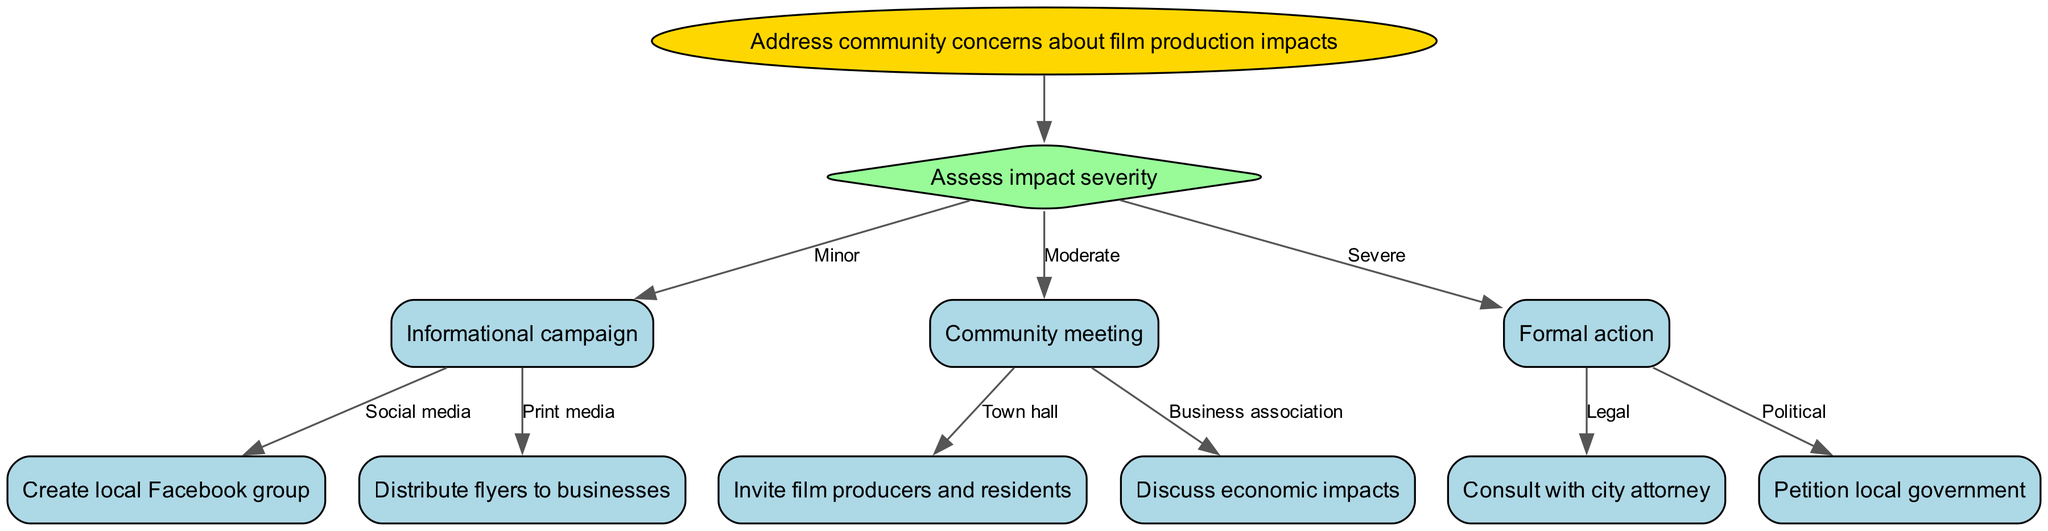What is the main goal of the decision tree? The root of the decision tree indicates that the primary focus is to "Address community concerns about film production impacts," which sets the context for the entire diagram.
Answer: Address community concerns about film production impacts How many options are available for moderate impact severity? The node for moderate impact severity presents two options: "Community meeting" allows for two specific actions, which are listed as separate paths.
Answer: 2 What is the first step if the impact is assessed as severe? The decision tree specifies that for severe impacts, the next step is "Formal action," directly following the assessment of the impact's severity.
Answer: Formal action Which method is suggested under minor impact severity? The "Minor" branch leads to two suggested methods: one is "Informational campaign," which directs to two options including "Create local Facebook group" and "Distribute flyers to businesses."
Answer: Informational campaign If choosing to consult with city attorney, what impact severity was initially assessed? To arrive at the option to "Consult with city attorney," one must first assess the impact severity as "Severe," which directs the decision-making process towards formal actions.
Answer: Severe What type of meeting is suggested under moderate impact severity? The diagram indicates that under the "Moderate" impact severity, a "Community meeting" is recommended, with further specific types of meetings provided as options.
Answer: Community meeting What follows after the "Town hall" node? Following the "Town hall" node, the diagram outlines that the next step involves inviting film producers and residents to discuss the impact.
Answer: Invite film producers and residents If the edge is "Legal," which action needs to be taken? The edge labeled "Legal" leads to the action of "Consult with city attorney," which outlines the legal step to take in response to the assessed severity of impact.
Answer: Consult with city attorney How does the decision tree classify the nature of impact as assessed? The tree classifies the impact severity into three categories: Minor, Moderate, and Severe, each leading to specific recommended actions based on the assessment.
Answer: Minor, Moderate, Severe 